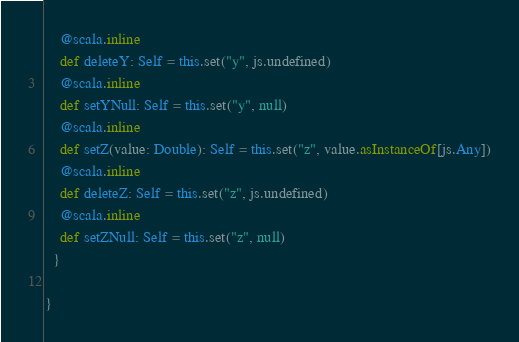<code> <loc_0><loc_0><loc_500><loc_500><_Scala_>    @scala.inline
    def deleteY: Self = this.set("y", js.undefined)
    @scala.inline
    def setYNull: Self = this.set("y", null)
    @scala.inline
    def setZ(value: Double): Self = this.set("z", value.asInstanceOf[js.Any])
    @scala.inline
    def deleteZ: Self = this.set("z", js.undefined)
    @scala.inline
    def setZNull: Self = this.set("z", null)
  }
  
}

</code> 